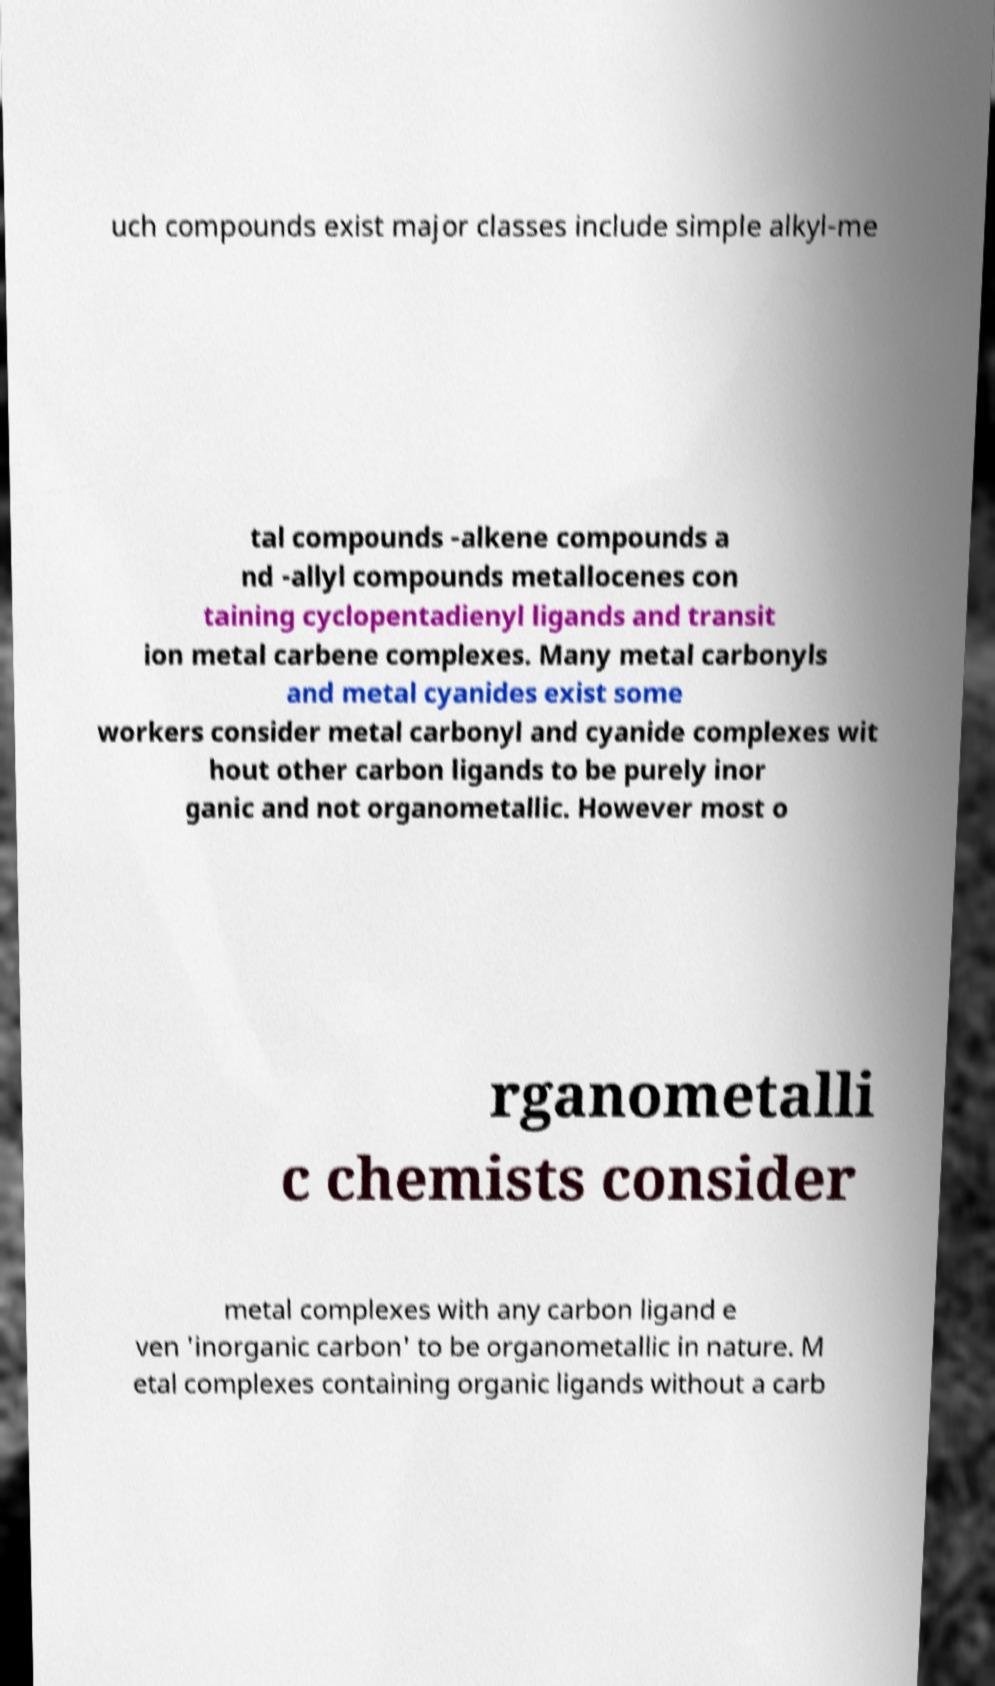Please read and relay the text visible in this image. What does it say? uch compounds exist major classes include simple alkyl-me tal compounds -alkene compounds a nd -allyl compounds metallocenes con taining cyclopentadienyl ligands and transit ion metal carbene complexes. Many metal carbonyls and metal cyanides exist some workers consider metal carbonyl and cyanide complexes wit hout other carbon ligands to be purely inor ganic and not organometallic. However most o rganometalli c chemists consider metal complexes with any carbon ligand e ven 'inorganic carbon' to be organometallic in nature. M etal complexes containing organic ligands without a carb 